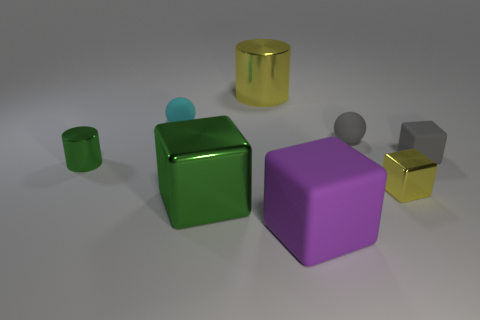There is a metal thing that is both on the right side of the big green shiny block and behind the tiny yellow object; what is its shape?
Your response must be concise. Cylinder. Do the small rubber cube and the big cylinder have the same color?
Your answer should be compact. No. There is another matte object that is the same shape as the purple rubber thing; what is its size?
Provide a succinct answer. Small. Are there any other things that have the same material as the big purple block?
Your answer should be compact. Yes. The big green object is what shape?
Provide a short and direct response. Cube. There is a yellow metal object that is the same size as the gray ball; what shape is it?
Your response must be concise. Cube. Is there any other thing that is the same color as the big rubber cube?
Keep it short and to the point. No. What is the size of the gray sphere that is made of the same material as the cyan ball?
Offer a very short reply. Small. Does the small yellow thing have the same shape as the green metal thing left of the small cyan rubber ball?
Make the answer very short. No. What size is the purple object?
Make the answer very short. Large. 